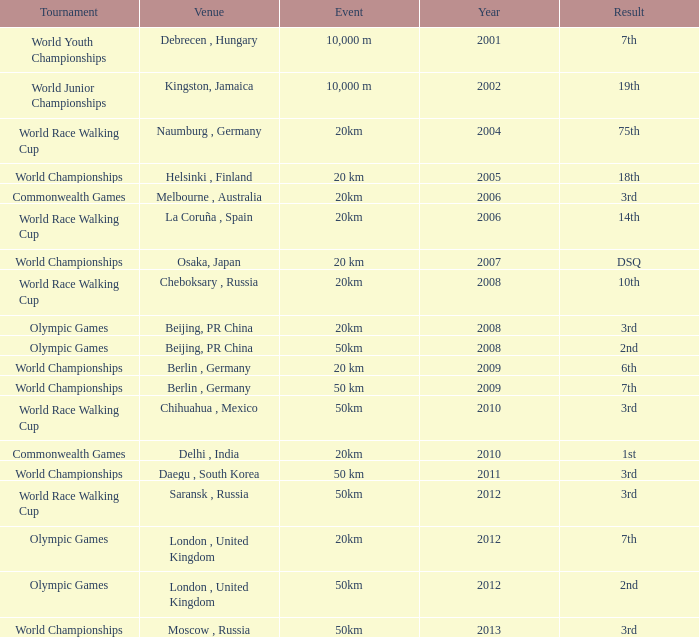What is the result of the World Race Walking Cup tournament played before the year 2010? 3rd. 